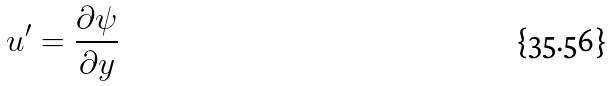<formula> <loc_0><loc_0><loc_500><loc_500>u ^ { \prime } = \frac { \partial \psi } { \partial y }</formula> 